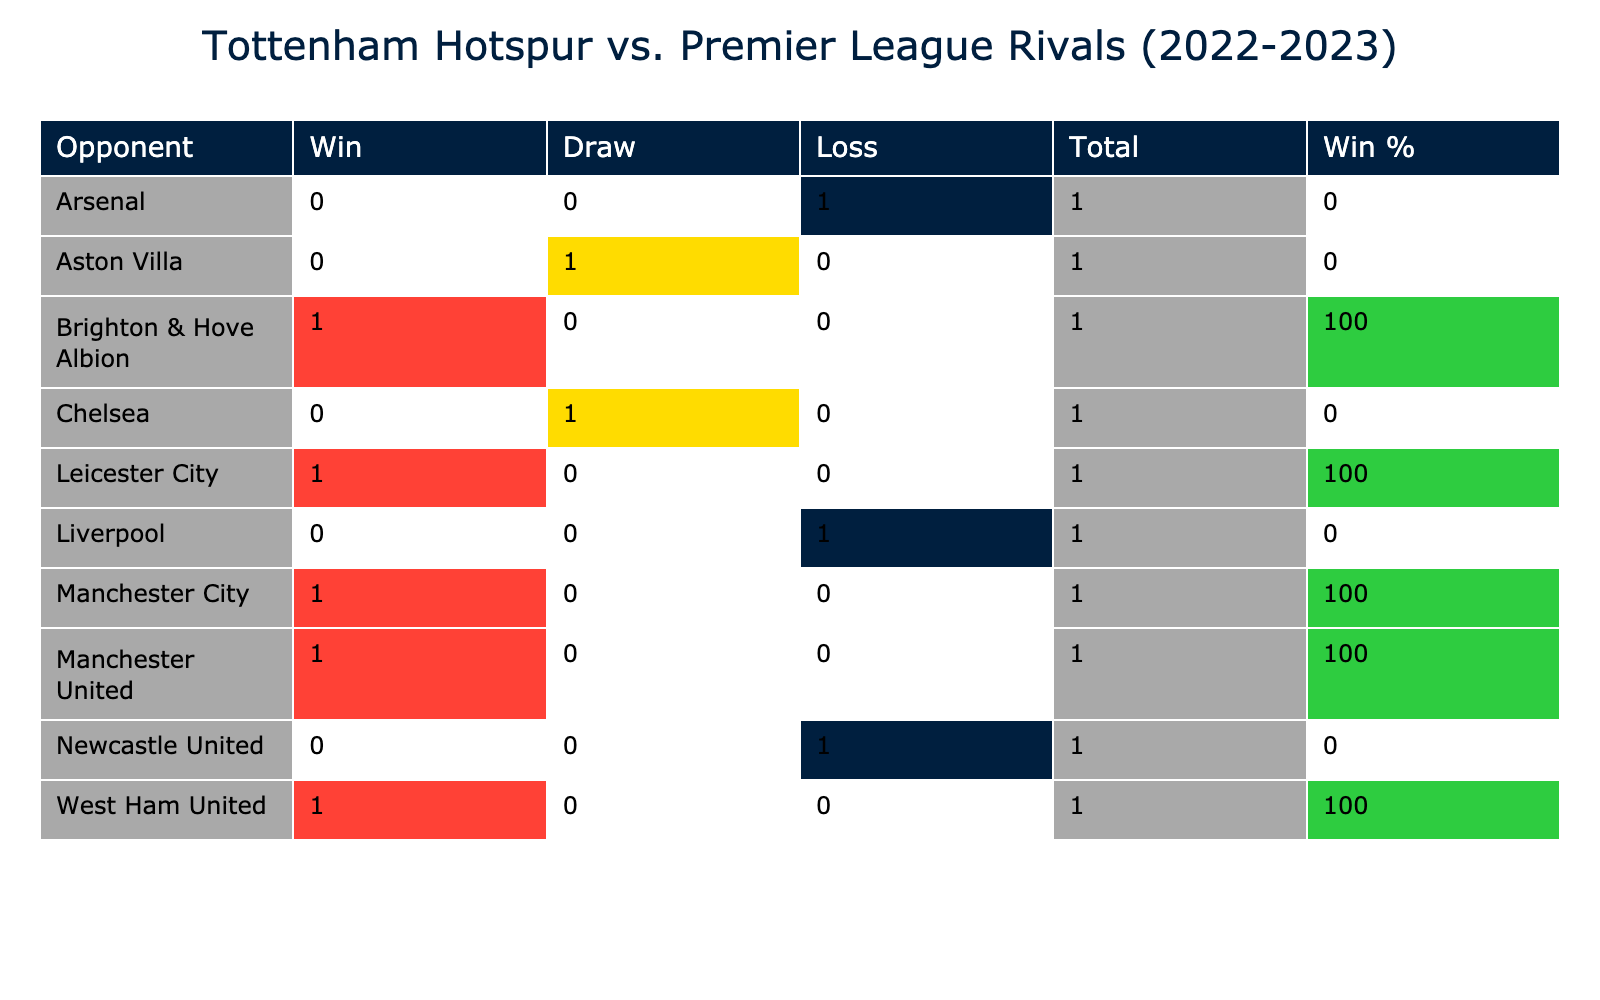What was the result of the match against Arsenal? The table shows that Tottenham Hotspur played against Arsenal at home and the result was a loss.
Answer: Loss How many times did Tottenham win against Manchester City? From the table, it is clear that Tottenham won against Manchester City once, as indicated in the 'Win' column for that opponent.
Answer: 1 Did Tottenham ever draw a match against Chelsea? The table indicates that Tottenham drew once against Chelsea during the season, as evidenced by the 'Draw' column value for that opponent.
Answer: Yes What is Tottenham's win percentage against Leicester City? Tottenham played one match against Leicester City, where they won. The win percentage is calculated as (1 win / 1 total match) * 100, so the win percentage is 100%.
Answer: 100% How many matches did Tottenham lose at home? The data shows that Tottenham lost one match at home (against Arsenal). By counting the matches listed under 'Home' in the table, we can see there are only two home matches played, and one was a loss.
Answer: 1 Which opponent did Tottenham achieve the highest number of goals against? By examining the 'Goals For' column, it shows that Tottenham scored 4 goals against Leicester City, which is the highest among the opponents listed.
Answer: Leicester City What is the total number of matches Tottenham played against London rivals? Tottenham played 5 matches against London rivals (Arsenal, Chelsea, and West Ham United). By summing the relevant rows, we see Arsenal (1), Chelsea (1), West Ham United (1), and Chelsea (match listed as an away game).
Answer: 3 How did Tottenham perform against opponents where they scored 1 goal? In the table, Tottenham scored 1 goal in two matches (against Arsenal and Aston Villa). In both matches, they either lost or drew. Therefore, Tottenham didn't win any match when they scored just 1 goal.
Answer: Did not win any matches What was the overall outcome of Tottenham's matches against the top six clubs? The top six clubs, including Arsenal, Manchester City, and Manchester United have been played against. In total, they lost to Arsenal and Liverpool, won against Manchester City and Manchester United, and drew against Chelsea, resulting in a mixed performance with two wins, two losses, and one draw.
Answer: Mixed performance 